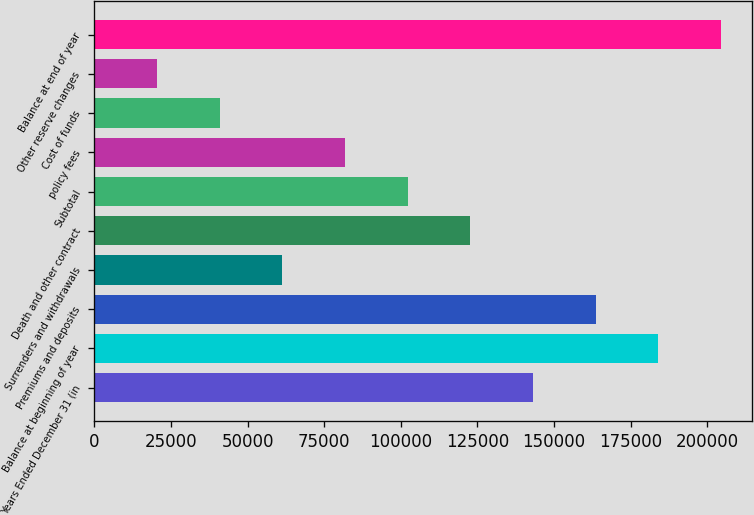Convert chart to OTSL. <chart><loc_0><loc_0><loc_500><loc_500><bar_chart><fcel>Years Ended December 31 (in<fcel>Balance at beginning of year<fcel>Premiums and deposits<fcel>Surrenders and withdrawals<fcel>Death and other contract<fcel>Subtotal<fcel>policy fees<fcel>Cost of funds<fcel>Other reserve changes<fcel>Balance at end of year<nl><fcel>143063<fcel>183937<fcel>163500<fcel>61315.7<fcel>122626<fcel>102190<fcel>81752.6<fcel>40878.8<fcel>20441.9<fcel>204374<nl></chart> 